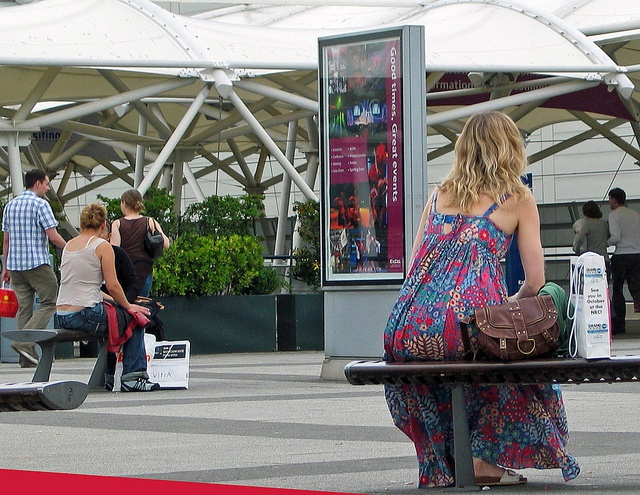Describe the objects in this image and their specific colors. I can see people in gray, black, and darkgray tones, bench in gray, black, darkgray, and purple tones, people in gray, black, darkgray, brown, and maroon tones, people in gray, black, and darkgray tones, and handbag in gray, brown, black, and maroon tones in this image. 